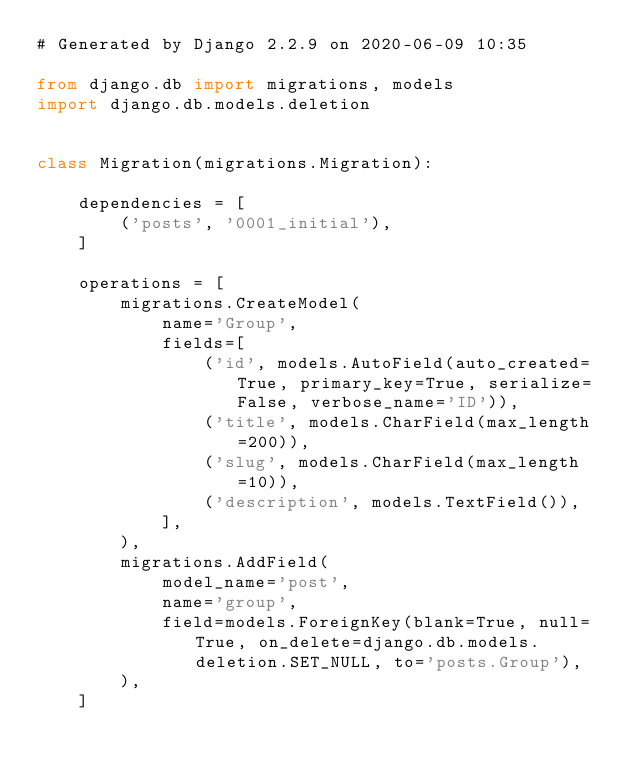<code> <loc_0><loc_0><loc_500><loc_500><_Python_># Generated by Django 2.2.9 on 2020-06-09 10:35

from django.db import migrations, models
import django.db.models.deletion


class Migration(migrations.Migration):

    dependencies = [
        ('posts', '0001_initial'),
    ]

    operations = [
        migrations.CreateModel(
            name='Group',
            fields=[
                ('id', models.AutoField(auto_created=True, primary_key=True, serialize=False, verbose_name='ID')),
                ('title', models.CharField(max_length=200)),
                ('slug', models.CharField(max_length=10)),
                ('description', models.TextField()),
            ],
        ),
        migrations.AddField(
            model_name='post',
            name='group',
            field=models.ForeignKey(blank=True, null=True, on_delete=django.db.models.deletion.SET_NULL, to='posts.Group'),
        ),
    ]
</code> 